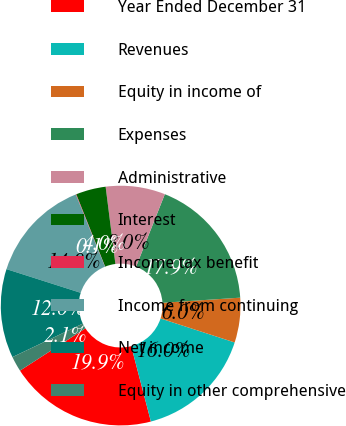Convert chart. <chart><loc_0><loc_0><loc_500><loc_500><pie_chart><fcel>Year Ended December 31<fcel>Revenues<fcel>Equity in income of<fcel>Expenses<fcel>Administrative<fcel>Interest<fcel>Income tax benefit<fcel>Income from continuing<fcel>Net income<fcel>Equity in other comprehensive<nl><fcel>19.93%<fcel>15.96%<fcel>6.03%<fcel>17.94%<fcel>8.01%<fcel>4.04%<fcel>0.07%<fcel>13.97%<fcel>11.99%<fcel>2.06%<nl></chart> 